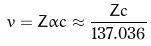<formula> <loc_0><loc_0><loc_500><loc_500>v = Z \alpha c \approx \frac { Z c } { 1 3 7 . 0 3 6 }</formula> 